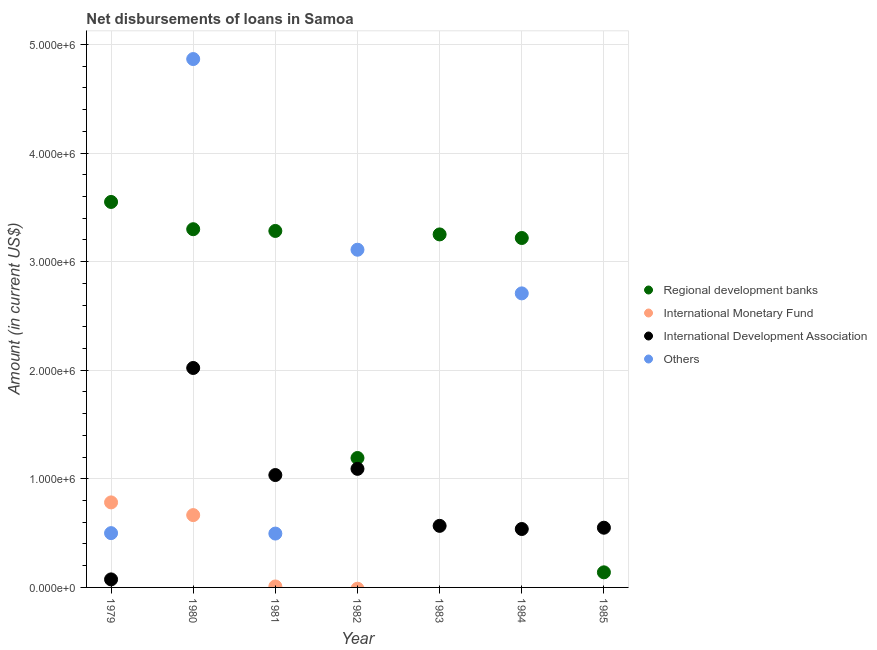How many different coloured dotlines are there?
Ensure brevity in your answer.  4. What is the amount of loan disimbursed by other organisations in 1980?
Make the answer very short. 4.87e+06. Across all years, what is the maximum amount of loan disimbursed by international development association?
Offer a terse response. 2.02e+06. Across all years, what is the minimum amount of loan disimbursed by international development association?
Offer a terse response. 7.40e+04. What is the total amount of loan disimbursed by international development association in the graph?
Offer a very short reply. 5.88e+06. What is the difference between the amount of loan disimbursed by regional development banks in 1979 and that in 1982?
Ensure brevity in your answer.  2.36e+06. What is the difference between the amount of loan disimbursed by international development association in 1979 and the amount of loan disimbursed by other organisations in 1984?
Offer a very short reply. -2.63e+06. What is the average amount of loan disimbursed by other organisations per year?
Your response must be concise. 1.67e+06. In the year 1979, what is the difference between the amount of loan disimbursed by regional development banks and amount of loan disimbursed by international monetary fund?
Your response must be concise. 2.77e+06. What is the ratio of the amount of loan disimbursed by international development association in 1981 to that in 1984?
Keep it short and to the point. 1.92. What is the difference between the highest and the second highest amount of loan disimbursed by international monetary fund?
Your response must be concise. 1.17e+05. What is the difference between the highest and the lowest amount of loan disimbursed by regional development banks?
Offer a very short reply. 3.41e+06. Is it the case that in every year, the sum of the amount of loan disimbursed by regional development banks and amount of loan disimbursed by international monetary fund is greater than the amount of loan disimbursed by international development association?
Your answer should be compact. No. Does the amount of loan disimbursed by regional development banks monotonically increase over the years?
Offer a terse response. No. Is the amount of loan disimbursed by other organisations strictly greater than the amount of loan disimbursed by international development association over the years?
Your answer should be very brief. No. How many dotlines are there?
Keep it short and to the point. 4. How many years are there in the graph?
Provide a succinct answer. 7. How many legend labels are there?
Your answer should be compact. 4. What is the title of the graph?
Keep it short and to the point. Net disbursements of loans in Samoa. Does "Revenue mobilization" appear as one of the legend labels in the graph?
Keep it short and to the point. No. What is the label or title of the X-axis?
Your response must be concise. Year. What is the label or title of the Y-axis?
Keep it short and to the point. Amount (in current US$). What is the Amount (in current US$) of Regional development banks in 1979?
Keep it short and to the point. 3.55e+06. What is the Amount (in current US$) in International Monetary Fund in 1979?
Offer a very short reply. 7.83e+05. What is the Amount (in current US$) in International Development Association in 1979?
Your answer should be very brief. 7.40e+04. What is the Amount (in current US$) in Regional development banks in 1980?
Provide a short and direct response. 3.30e+06. What is the Amount (in current US$) in International Monetary Fund in 1980?
Provide a short and direct response. 6.66e+05. What is the Amount (in current US$) of International Development Association in 1980?
Ensure brevity in your answer.  2.02e+06. What is the Amount (in current US$) in Others in 1980?
Offer a very short reply. 4.87e+06. What is the Amount (in current US$) of Regional development banks in 1981?
Make the answer very short. 3.28e+06. What is the Amount (in current US$) of International Monetary Fund in 1981?
Ensure brevity in your answer.  9000. What is the Amount (in current US$) of International Development Association in 1981?
Your response must be concise. 1.04e+06. What is the Amount (in current US$) of Others in 1981?
Provide a succinct answer. 4.96e+05. What is the Amount (in current US$) of Regional development banks in 1982?
Your answer should be very brief. 1.19e+06. What is the Amount (in current US$) of International Monetary Fund in 1982?
Offer a terse response. 0. What is the Amount (in current US$) in International Development Association in 1982?
Your answer should be compact. 1.09e+06. What is the Amount (in current US$) of Others in 1982?
Offer a very short reply. 3.11e+06. What is the Amount (in current US$) of Regional development banks in 1983?
Your answer should be very brief. 3.25e+06. What is the Amount (in current US$) in International Monetary Fund in 1983?
Keep it short and to the point. 0. What is the Amount (in current US$) in International Development Association in 1983?
Your answer should be compact. 5.67e+05. What is the Amount (in current US$) of Others in 1983?
Offer a terse response. 0. What is the Amount (in current US$) in Regional development banks in 1984?
Your answer should be compact. 3.22e+06. What is the Amount (in current US$) in International Development Association in 1984?
Your response must be concise. 5.38e+05. What is the Amount (in current US$) in Others in 1984?
Offer a very short reply. 2.71e+06. What is the Amount (in current US$) in Regional development banks in 1985?
Your answer should be very brief. 1.39e+05. What is the Amount (in current US$) of International Monetary Fund in 1985?
Keep it short and to the point. 0. Across all years, what is the maximum Amount (in current US$) in Regional development banks?
Ensure brevity in your answer.  3.55e+06. Across all years, what is the maximum Amount (in current US$) in International Monetary Fund?
Your answer should be very brief. 7.83e+05. Across all years, what is the maximum Amount (in current US$) of International Development Association?
Ensure brevity in your answer.  2.02e+06. Across all years, what is the maximum Amount (in current US$) in Others?
Provide a short and direct response. 4.87e+06. Across all years, what is the minimum Amount (in current US$) in Regional development banks?
Keep it short and to the point. 1.39e+05. Across all years, what is the minimum Amount (in current US$) in International Monetary Fund?
Provide a succinct answer. 0. Across all years, what is the minimum Amount (in current US$) of International Development Association?
Provide a short and direct response. 7.40e+04. What is the total Amount (in current US$) in Regional development banks in the graph?
Offer a very short reply. 1.79e+07. What is the total Amount (in current US$) of International Monetary Fund in the graph?
Your answer should be compact. 1.46e+06. What is the total Amount (in current US$) of International Development Association in the graph?
Provide a succinct answer. 5.88e+06. What is the total Amount (in current US$) in Others in the graph?
Your answer should be compact. 1.17e+07. What is the difference between the Amount (in current US$) in Regional development banks in 1979 and that in 1980?
Provide a succinct answer. 2.51e+05. What is the difference between the Amount (in current US$) in International Monetary Fund in 1979 and that in 1980?
Your answer should be very brief. 1.17e+05. What is the difference between the Amount (in current US$) in International Development Association in 1979 and that in 1980?
Offer a very short reply. -1.95e+06. What is the difference between the Amount (in current US$) in Others in 1979 and that in 1980?
Offer a very short reply. -4.37e+06. What is the difference between the Amount (in current US$) in Regional development banks in 1979 and that in 1981?
Give a very brief answer. 2.67e+05. What is the difference between the Amount (in current US$) of International Monetary Fund in 1979 and that in 1981?
Your answer should be very brief. 7.74e+05. What is the difference between the Amount (in current US$) in International Development Association in 1979 and that in 1981?
Your answer should be compact. -9.61e+05. What is the difference between the Amount (in current US$) of Others in 1979 and that in 1981?
Keep it short and to the point. 4000. What is the difference between the Amount (in current US$) of Regional development banks in 1979 and that in 1982?
Ensure brevity in your answer.  2.36e+06. What is the difference between the Amount (in current US$) in International Development Association in 1979 and that in 1982?
Provide a succinct answer. -1.02e+06. What is the difference between the Amount (in current US$) in Others in 1979 and that in 1982?
Offer a terse response. -2.61e+06. What is the difference between the Amount (in current US$) in Regional development banks in 1979 and that in 1983?
Ensure brevity in your answer.  2.99e+05. What is the difference between the Amount (in current US$) in International Development Association in 1979 and that in 1983?
Offer a terse response. -4.93e+05. What is the difference between the Amount (in current US$) of Regional development banks in 1979 and that in 1984?
Your answer should be very brief. 3.32e+05. What is the difference between the Amount (in current US$) of International Development Association in 1979 and that in 1984?
Provide a succinct answer. -4.64e+05. What is the difference between the Amount (in current US$) of Others in 1979 and that in 1984?
Ensure brevity in your answer.  -2.21e+06. What is the difference between the Amount (in current US$) in Regional development banks in 1979 and that in 1985?
Your response must be concise. 3.41e+06. What is the difference between the Amount (in current US$) of International Development Association in 1979 and that in 1985?
Provide a short and direct response. -4.76e+05. What is the difference between the Amount (in current US$) of Regional development banks in 1980 and that in 1981?
Offer a terse response. 1.60e+04. What is the difference between the Amount (in current US$) of International Monetary Fund in 1980 and that in 1981?
Your answer should be very brief. 6.57e+05. What is the difference between the Amount (in current US$) of International Development Association in 1980 and that in 1981?
Your response must be concise. 9.86e+05. What is the difference between the Amount (in current US$) in Others in 1980 and that in 1981?
Ensure brevity in your answer.  4.37e+06. What is the difference between the Amount (in current US$) of Regional development banks in 1980 and that in 1982?
Ensure brevity in your answer.  2.11e+06. What is the difference between the Amount (in current US$) of International Development Association in 1980 and that in 1982?
Your answer should be very brief. 9.29e+05. What is the difference between the Amount (in current US$) of Others in 1980 and that in 1982?
Provide a short and direct response. 1.76e+06. What is the difference between the Amount (in current US$) of Regional development banks in 1980 and that in 1983?
Offer a very short reply. 4.80e+04. What is the difference between the Amount (in current US$) of International Development Association in 1980 and that in 1983?
Your answer should be compact. 1.45e+06. What is the difference between the Amount (in current US$) in Regional development banks in 1980 and that in 1984?
Your answer should be very brief. 8.10e+04. What is the difference between the Amount (in current US$) of International Development Association in 1980 and that in 1984?
Provide a succinct answer. 1.48e+06. What is the difference between the Amount (in current US$) of Others in 1980 and that in 1984?
Give a very brief answer. 2.16e+06. What is the difference between the Amount (in current US$) of Regional development banks in 1980 and that in 1985?
Make the answer very short. 3.16e+06. What is the difference between the Amount (in current US$) of International Development Association in 1980 and that in 1985?
Give a very brief answer. 1.47e+06. What is the difference between the Amount (in current US$) in Regional development banks in 1981 and that in 1982?
Provide a succinct answer. 2.09e+06. What is the difference between the Amount (in current US$) in International Development Association in 1981 and that in 1982?
Ensure brevity in your answer.  -5.70e+04. What is the difference between the Amount (in current US$) of Others in 1981 and that in 1982?
Offer a very short reply. -2.61e+06. What is the difference between the Amount (in current US$) of Regional development banks in 1981 and that in 1983?
Your response must be concise. 3.20e+04. What is the difference between the Amount (in current US$) of International Development Association in 1981 and that in 1983?
Your answer should be compact. 4.68e+05. What is the difference between the Amount (in current US$) of Regional development banks in 1981 and that in 1984?
Your answer should be very brief. 6.50e+04. What is the difference between the Amount (in current US$) of International Development Association in 1981 and that in 1984?
Your answer should be compact. 4.97e+05. What is the difference between the Amount (in current US$) in Others in 1981 and that in 1984?
Your answer should be compact. -2.21e+06. What is the difference between the Amount (in current US$) in Regional development banks in 1981 and that in 1985?
Offer a terse response. 3.14e+06. What is the difference between the Amount (in current US$) in International Development Association in 1981 and that in 1985?
Give a very brief answer. 4.85e+05. What is the difference between the Amount (in current US$) of Regional development banks in 1982 and that in 1983?
Your answer should be very brief. -2.06e+06. What is the difference between the Amount (in current US$) of International Development Association in 1982 and that in 1983?
Ensure brevity in your answer.  5.25e+05. What is the difference between the Amount (in current US$) in Regional development banks in 1982 and that in 1984?
Offer a very short reply. -2.03e+06. What is the difference between the Amount (in current US$) of International Development Association in 1982 and that in 1984?
Your response must be concise. 5.54e+05. What is the difference between the Amount (in current US$) of Others in 1982 and that in 1984?
Provide a short and direct response. 4.02e+05. What is the difference between the Amount (in current US$) in Regional development banks in 1982 and that in 1985?
Your response must be concise. 1.05e+06. What is the difference between the Amount (in current US$) in International Development Association in 1982 and that in 1985?
Offer a terse response. 5.42e+05. What is the difference between the Amount (in current US$) in Regional development banks in 1983 and that in 1984?
Your response must be concise. 3.30e+04. What is the difference between the Amount (in current US$) in International Development Association in 1983 and that in 1984?
Your response must be concise. 2.90e+04. What is the difference between the Amount (in current US$) in Regional development banks in 1983 and that in 1985?
Give a very brief answer. 3.11e+06. What is the difference between the Amount (in current US$) in International Development Association in 1983 and that in 1985?
Offer a very short reply. 1.70e+04. What is the difference between the Amount (in current US$) of Regional development banks in 1984 and that in 1985?
Give a very brief answer. 3.08e+06. What is the difference between the Amount (in current US$) in International Development Association in 1984 and that in 1985?
Ensure brevity in your answer.  -1.20e+04. What is the difference between the Amount (in current US$) of Regional development banks in 1979 and the Amount (in current US$) of International Monetary Fund in 1980?
Provide a short and direct response. 2.88e+06. What is the difference between the Amount (in current US$) in Regional development banks in 1979 and the Amount (in current US$) in International Development Association in 1980?
Provide a succinct answer. 1.53e+06. What is the difference between the Amount (in current US$) of Regional development banks in 1979 and the Amount (in current US$) of Others in 1980?
Provide a succinct answer. -1.32e+06. What is the difference between the Amount (in current US$) of International Monetary Fund in 1979 and the Amount (in current US$) of International Development Association in 1980?
Provide a short and direct response. -1.24e+06. What is the difference between the Amount (in current US$) of International Monetary Fund in 1979 and the Amount (in current US$) of Others in 1980?
Ensure brevity in your answer.  -4.08e+06. What is the difference between the Amount (in current US$) in International Development Association in 1979 and the Amount (in current US$) in Others in 1980?
Keep it short and to the point. -4.79e+06. What is the difference between the Amount (in current US$) in Regional development banks in 1979 and the Amount (in current US$) in International Monetary Fund in 1981?
Your answer should be compact. 3.54e+06. What is the difference between the Amount (in current US$) in Regional development banks in 1979 and the Amount (in current US$) in International Development Association in 1981?
Keep it short and to the point. 2.52e+06. What is the difference between the Amount (in current US$) of Regional development banks in 1979 and the Amount (in current US$) of Others in 1981?
Offer a terse response. 3.05e+06. What is the difference between the Amount (in current US$) of International Monetary Fund in 1979 and the Amount (in current US$) of International Development Association in 1981?
Give a very brief answer. -2.52e+05. What is the difference between the Amount (in current US$) of International Monetary Fund in 1979 and the Amount (in current US$) of Others in 1981?
Keep it short and to the point. 2.87e+05. What is the difference between the Amount (in current US$) of International Development Association in 1979 and the Amount (in current US$) of Others in 1981?
Keep it short and to the point. -4.22e+05. What is the difference between the Amount (in current US$) of Regional development banks in 1979 and the Amount (in current US$) of International Development Association in 1982?
Provide a succinct answer. 2.46e+06. What is the difference between the Amount (in current US$) in International Monetary Fund in 1979 and the Amount (in current US$) in International Development Association in 1982?
Provide a succinct answer. -3.09e+05. What is the difference between the Amount (in current US$) of International Monetary Fund in 1979 and the Amount (in current US$) of Others in 1982?
Offer a terse response. -2.33e+06. What is the difference between the Amount (in current US$) of International Development Association in 1979 and the Amount (in current US$) of Others in 1982?
Keep it short and to the point. -3.04e+06. What is the difference between the Amount (in current US$) of Regional development banks in 1979 and the Amount (in current US$) of International Development Association in 1983?
Keep it short and to the point. 2.98e+06. What is the difference between the Amount (in current US$) of International Monetary Fund in 1979 and the Amount (in current US$) of International Development Association in 1983?
Give a very brief answer. 2.16e+05. What is the difference between the Amount (in current US$) of Regional development banks in 1979 and the Amount (in current US$) of International Development Association in 1984?
Your answer should be very brief. 3.01e+06. What is the difference between the Amount (in current US$) of Regional development banks in 1979 and the Amount (in current US$) of Others in 1984?
Keep it short and to the point. 8.42e+05. What is the difference between the Amount (in current US$) in International Monetary Fund in 1979 and the Amount (in current US$) in International Development Association in 1984?
Provide a short and direct response. 2.45e+05. What is the difference between the Amount (in current US$) of International Monetary Fund in 1979 and the Amount (in current US$) of Others in 1984?
Offer a terse response. -1.92e+06. What is the difference between the Amount (in current US$) in International Development Association in 1979 and the Amount (in current US$) in Others in 1984?
Make the answer very short. -2.63e+06. What is the difference between the Amount (in current US$) of Regional development banks in 1979 and the Amount (in current US$) of International Development Association in 1985?
Offer a terse response. 3.00e+06. What is the difference between the Amount (in current US$) of International Monetary Fund in 1979 and the Amount (in current US$) of International Development Association in 1985?
Make the answer very short. 2.33e+05. What is the difference between the Amount (in current US$) of Regional development banks in 1980 and the Amount (in current US$) of International Monetary Fund in 1981?
Give a very brief answer. 3.29e+06. What is the difference between the Amount (in current US$) in Regional development banks in 1980 and the Amount (in current US$) in International Development Association in 1981?
Your response must be concise. 2.26e+06. What is the difference between the Amount (in current US$) of Regional development banks in 1980 and the Amount (in current US$) of Others in 1981?
Your answer should be compact. 2.80e+06. What is the difference between the Amount (in current US$) of International Monetary Fund in 1980 and the Amount (in current US$) of International Development Association in 1981?
Ensure brevity in your answer.  -3.69e+05. What is the difference between the Amount (in current US$) in International Development Association in 1980 and the Amount (in current US$) in Others in 1981?
Offer a terse response. 1.52e+06. What is the difference between the Amount (in current US$) of Regional development banks in 1980 and the Amount (in current US$) of International Development Association in 1982?
Ensure brevity in your answer.  2.21e+06. What is the difference between the Amount (in current US$) of Regional development banks in 1980 and the Amount (in current US$) of Others in 1982?
Offer a terse response. 1.89e+05. What is the difference between the Amount (in current US$) of International Monetary Fund in 1980 and the Amount (in current US$) of International Development Association in 1982?
Offer a very short reply. -4.26e+05. What is the difference between the Amount (in current US$) of International Monetary Fund in 1980 and the Amount (in current US$) of Others in 1982?
Keep it short and to the point. -2.44e+06. What is the difference between the Amount (in current US$) in International Development Association in 1980 and the Amount (in current US$) in Others in 1982?
Provide a short and direct response. -1.09e+06. What is the difference between the Amount (in current US$) of Regional development banks in 1980 and the Amount (in current US$) of International Development Association in 1983?
Your answer should be compact. 2.73e+06. What is the difference between the Amount (in current US$) in International Monetary Fund in 1980 and the Amount (in current US$) in International Development Association in 1983?
Keep it short and to the point. 9.90e+04. What is the difference between the Amount (in current US$) of Regional development banks in 1980 and the Amount (in current US$) of International Development Association in 1984?
Give a very brief answer. 2.76e+06. What is the difference between the Amount (in current US$) of Regional development banks in 1980 and the Amount (in current US$) of Others in 1984?
Provide a short and direct response. 5.91e+05. What is the difference between the Amount (in current US$) in International Monetary Fund in 1980 and the Amount (in current US$) in International Development Association in 1984?
Offer a very short reply. 1.28e+05. What is the difference between the Amount (in current US$) of International Monetary Fund in 1980 and the Amount (in current US$) of Others in 1984?
Provide a short and direct response. -2.04e+06. What is the difference between the Amount (in current US$) in International Development Association in 1980 and the Amount (in current US$) in Others in 1984?
Your answer should be very brief. -6.87e+05. What is the difference between the Amount (in current US$) of Regional development banks in 1980 and the Amount (in current US$) of International Development Association in 1985?
Offer a very short reply. 2.75e+06. What is the difference between the Amount (in current US$) in International Monetary Fund in 1980 and the Amount (in current US$) in International Development Association in 1985?
Your response must be concise. 1.16e+05. What is the difference between the Amount (in current US$) in Regional development banks in 1981 and the Amount (in current US$) in International Development Association in 1982?
Your response must be concise. 2.19e+06. What is the difference between the Amount (in current US$) in Regional development banks in 1981 and the Amount (in current US$) in Others in 1982?
Ensure brevity in your answer.  1.73e+05. What is the difference between the Amount (in current US$) in International Monetary Fund in 1981 and the Amount (in current US$) in International Development Association in 1982?
Keep it short and to the point. -1.08e+06. What is the difference between the Amount (in current US$) in International Monetary Fund in 1981 and the Amount (in current US$) in Others in 1982?
Ensure brevity in your answer.  -3.10e+06. What is the difference between the Amount (in current US$) in International Development Association in 1981 and the Amount (in current US$) in Others in 1982?
Your response must be concise. -2.08e+06. What is the difference between the Amount (in current US$) of Regional development banks in 1981 and the Amount (in current US$) of International Development Association in 1983?
Offer a terse response. 2.72e+06. What is the difference between the Amount (in current US$) in International Monetary Fund in 1981 and the Amount (in current US$) in International Development Association in 1983?
Give a very brief answer. -5.58e+05. What is the difference between the Amount (in current US$) of Regional development banks in 1981 and the Amount (in current US$) of International Development Association in 1984?
Ensure brevity in your answer.  2.74e+06. What is the difference between the Amount (in current US$) in Regional development banks in 1981 and the Amount (in current US$) in Others in 1984?
Your answer should be compact. 5.75e+05. What is the difference between the Amount (in current US$) of International Monetary Fund in 1981 and the Amount (in current US$) of International Development Association in 1984?
Make the answer very short. -5.29e+05. What is the difference between the Amount (in current US$) of International Monetary Fund in 1981 and the Amount (in current US$) of Others in 1984?
Offer a very short reply. -2.70e+06. What is the difference between the Amount (in current US$) of International Development Association in 1981 and the Amount (in current US$) of Others in 1984?
Offer a terse response. -1.67e+06. What is the difference between the Amount (in current US$) in Regional development banks in 1981 and the Amount (in current US$) in International Development Association in 1985?
Give a very brief answer. 2.73e+06. What is the difference between the Amount (in current US$) of International Monetary Fund in 1981 and the Amount (in current US$) of International Development Association in 1985?
Offer a very short reply. -5.41e+05. What is the difference between the Amount (in current US$) of Regional development banks in 1982 and the Amount (in current US$) of International Development Association in 1983?
Offer a very short reply. 6.25e+05. What is the difference between the Amount (in current US$) of Regional development banks in 1982 and the Amount (in current US$) of International Development Association in 1984?
Your answer should be very brief. 6.54e+05. What is the difference between the Amount (in current US$) of Regional development banks in 1982 and the Amount (in current US$) of Others in 1984?
Your answer should be compact. -1.52e+06. What is the difference between the Amount (in current US$) in International Development Association in 1982 and the Amount (in current US$) in Others in 1984?
Keep it short and to the point. -1.62e+06. What is the difference between the Amount (in current US$) in Regional development banks in 1982 and the Amount (in current US$) in International Development Association in 1985?
Provide a succinct answer. 6.42e+05. What is the difference between the Amount (in current US$) of Regional development banks in 1983 and the Amount (in current US$) of International Development Association in 1984?
Provide a succinct answer. 2.71e+06. What is the difference between the Amount (in current US$) of Regional development banks in 1983 and the Amount (in current US$) of Others in 1984?
Provide a short and direct response. 5.43e+05. What is the difference between the Amount (in current US$) of International Development Association in 1983 and the Amount (in current US$) of Others in 1984?
Offer a terse response. -2.14e+06. What is the difference between the Amount (in current US$) of Regional development banks in 1983 and the Amount (in current US$) of International Development Association in 1985?
Keep it short and to the point. 2.70e+06. What is the difference between the Amount (in current US$) of Regional development banks in 1984 and the Amount (in current US$) of International Development Association in 1985?
Provide a succinct answer. 2.67e+06. What is the average Amount (in current US$) of Regional development banks per year?
Offer a terse response. 2.56e+06. What is the average Amount (in current US$) in International Monetary Fund per year?
Offer a terse response. 2.08e+05. What is the average Amount (in current US$) of International Development Association per year?
Your answer should be very brief. 8.40e+05. What is the average Amount (in current US$) of Others per year?
Make the answer very short. 1.67e+06. In the year 1979, what is the difference between the Amount (in current US$) of Regional development banks and Amount (in current US$) of International Monetary Fund?
Provide a succinct answer. 2.77e+06. In the year 1979, what is the difference between the Amount (in current US$) in Regional development banks and Amount (in current US$) in International Development Association?
Your response must be concise. 3.48e+06. In the year 1979, what is the difference between the Amount (in current US$) in Regional development banks and Amount (in current US$) in Others?
Keep it short and to the point. 3.05e+06. In the year 1979, what is the difference between the Amount (in current US$) of International Monetary Fund and Amount (in current US$) of International Development Association?
Provide a short and direct response. 7.09e+05. In the year 1979, what is the difference between the Amount (in current US$) in International Monetary Fund and Amount (in current US$) in Others?
Give a very brief answer. 2.83e+05. In the year 1979, what is the difference between the Amount (in current US$) in International Development Association and Amount (in current US$) in Others?
Make the answer very short. -4.26e+05. In the year 1980, what is the difference between the Amount (in current US$) of Regional development banks and Amount (in current US$) of International Monetary Fund?
Offer a terse response. 2.63e+06. In the year 1980, what is the difference between the Amount (in current US$) of Regional development banks and Amount (in current US$) of International Development Association?
Offer a terse response. 1.28e+06. In the year 1980, what is the difference between the Amount (in current US$) in Regional development banks and Amount (in current US$) in Others?
Provide a succinct answer. -1.57e+06. In the year 1980, what is the difference between the Amount (in current US$) in International Monetary Fund and Amount (in current US$) in International Development Association?
Offer a very short reply. -1.36e+06. In the year 1980, what is the difference between the Amount (in current US$) in International Monetary Fund and Amount (in current US$) in Others?
Offer a terse response. -4.20e+06. In the year 1980, what is the difference between the Amount (in current US$) of International Development Association and Amount (in current US$) of Others?
Your answer should be compact. -2.84e+06. In the year 1981, what is the difference between the Amount (in current US$) of Regional development banks and Amount (in current US$) of International Monetary Fund?
Your answer should be very brief. 3.27e+06. In the year 1981, what is the difference between the Amount (in current US$) of Regional development banks and Amount (in current US$) of International Development Association?
Provide a succinct answer. 2.25e+06. In the year 1981, what is the difference between the Amount (in current US$) of Regional development banks and Amount (in current US$) of Others?
Give a very brief answer. 2.79e+06. In the year 1981, what is the difference between the Amount (in current US$) in International Monetary Fund and Amount (in current US$) in International Development Association?
Keep it short and to the point. -1.03e+06. In the year 1981, what is the difference between the Amount (in current US$) of International Monetary Fund and Amount (in current US$) of Others?
Give a very brief answer. -4.87e+05. In the year 1981, what is the difference between the Amount (in current US$) in International Development Association and Amount (in current US$) in Others?
Give a very brief answer. 5.39e+05. In the year 1982, what is the difference between the Amount (in current US$) of Regional development banks and Amount (in current US$) of International Development Association?
Your answer should be very brief. 1.00e+05. In the year 1982, what is the difference between the Amount (in current US$) of Regional development banks and Amount (in current US$) of Others?
Offer a very short reply. -1.92e+06. In the year 1982, what is the difference between the Amount (in current US$) in International Development Association and Amount (in current US$) in Others?
Provide a succinct answer. -2.02e+06. In the year 1983, what is the difference between the Amount (in current US$) in Regional development banks and Amount (in current US$) in International Development Association?
Make the answer very short. 2.68e+06. In the year 1984, what is the difference between the Amount (in current US$) of Regional development banks and Amount (in current US$) of International Development Association?
Your answer should be compact. 2.68e+06. In the year 1984, what is the difference between the Amount (in current US$) in Regional development banks and Amount (in current US$) in Others?
Provide a succinct answer. 5.10e+05. In the year 1984, what is the difference between the Amount (in current US$) of International Development Association and Amount (in current US$) of Others?
Provide a succinct answer. -2.17e+06. In the year 1985, what is the difference between the Amount (in current US$) of Regional development banks and Amount (in current US$) of International Development Association?
Your response must be concise. -4.11e+05. What is the ratio of the Amount (in current US$) in Regional development banks in 1979 to that in 1980?
Give a very brief answer. 1.08. What is the ratio of the Amount (in current US$) of International Monetary Fund in 1979 to that in 1980?
Offer a terse response. 1.18. What is the ratio of the Amount (in current US$) in International Development Association in 1979 to that in 1980?
Your answer should be very brief. 0.04. What is the ratio of the Amount (in current US$) in Others in 1979 to that in 1980?
Keep it short and to the point. 0.1. What is the ratio of the Amount (in current US$) in Regional development banks in 1979 to that in 1981?
Ensure brevity in your answer.  1.08. What is the ratio of the Amount (in current US$) of International Development Association in 1979 to that in 1981?
Your answer should be compact. 0.07. What is the ratio of the Amount (in current US$) of Others in 1979 to that in 1981?
Offer a terse response. 1.01. What is the ratio of the Amount (in current US$) of Regional development banks in 1979 to that in 1982?
Provide a succinct answer. 2.98. What is the ratio of the Amount (in current US$) in International Development Association in 1979 to that in 1982?
Give a very brief answer. 0.07. What is the ratio of the Amount (in current US$) in Others in 1979 to that in 1982?
Make the answer very short. 0.16. What is the ratio of the Amount (in current US$) in Regional development banks in 1979 to that in 1983?
Give a very brief answer. 1.09. What is the ratio of the Amount (in current US$) of International Development Association in 1979 to that in 1983?
Make the answer very short. 0.13. What is the ratio of the Amount (in current US$) of Regional development banks in 1979 to that in 1984?
Keep it short and to the point. 1.1. What is the ratio of the Amount (in current US$) in International Development Association in 1979 to that in 1984?
Offer a very short reply. 0.14. What is the ratio of the Amount (in current US$) of Others in 1979 to that in 1984?
Offer a very short reply. 0.18. What is the ratio of the Amount (in current US$) of Regional development banks in 1979 to that in 1985?
Offer a terse response. 25.54. What is the ratio of the Amount (in current US$) of International Development Association in 1979 to that in 1985?
Provide a short and direct response. 0.13. What is the ratio of the Amount (in current US$) of Regional development banks in 1980 to that in 1981?
Offer a terse response. 1. What is the ratio of the Amount (in current US$) of International Development Association in 1980 to that in 1981?
Give a very brief answer. 1.95. What is the ratio of the Amount (in current US$) in Others in 1980 to that in 1981?
Offer a very short reply. 9.81. What is the ratio of the Amount (in current US$) of Regional development banks in 1980 to that in 1982?
Your response must be concise. 2.77. What is the ratio of the Amount (in current US$) of International Development Association in 1980 to that in 1982?
Provide a succinct answer. 1.85. What is the ratio of the Amount (in current US$) in Others in 1980 to that in 1982?
Your response must be concise. 1.56. What is the ratio of the Amount (in current US$) of Regional development banks in 1980 to that in 1983?
Keep it short and to the point. 1.01. What is the ratio of the Amount (in current US$) of International Development Association in 1980 to that in 1983?
Make the answer very short. 3.56. What is the ratio of the Amount (in current US$) of Regional development banks in 1980 to that in 1984?
Offer a very short reply. 1.03. What is the ratio of the Amount (in current US$) of International Development Association in 1980 to that in 1984?
Your answer should be very brief. 3.76. What is the ratio of the Amount (in current US$) in Others in 1980 to that in 1984?
Your response must be concise. 1.8. What is the ratio of the Amount (in current US$) of Regional development banks in 1980 to that in 1985?
Offer a terse response. 23.73. What is the ratio of the Amount (in current US$) in International Development Association in 1980 to that in 1985?
Keep it short and to the point. 3.67. What is the ratio of the Amount (in current US$) in Regional development banks in 1981 to that in 1982?
Your response must be concise. 2.75. What is the ratio of the Amount (in current US$) in International Development Association in 1981 to that in 1982?
Offer a terse response. 0.95. What is the ratio of the Amount (in current US$) of Others in 1981 to that in 1982?
Provide a succinct answer. 0.16. What is the ratio of the Amount (in current US$) of Regional development banks in 1981 to that in 1983?
Your answer should be compact. 1.01. What is the ratio of the Amount (in current US$) of International Development Association in 1981 to that in 1983?
Provide a succinct answer. 1.83. What is the ratio of the Amount (in current US$) in Regional development banks in 1981 to that in 1984?
Keep it short and to the point. 1.02. What is the ratio of the Amount (in current US$) in International Development Association in 1981 to that in 1984?
Keep it short and to the point. 1.92. What is the ratio of the Amount (in current US$) of Others in 1981 to that in 1984?
Provide a short and direct response. 0.18. What is the ratio of the Amount (in current US$) of Regional development banks in 1981 to that in 1985?
Ensure brevity in your answer.  23.62. What is the ratio of the Amount (in current US$) of International Development Association in 1981 to that in 1985?
Your response must be concise. 1.88. What is the ratio of the Amount (in current US$) of Regional development banks in 1982 to that in 1983?
Keep it short and to the point. 0.37. What is the ratio of the Amount (in current US$) in International Development Association in 1982 to that in 1983?
Make the answer very short. 1.93. What is the ratio of the Amount (in current US$) in Regional development banks in 1982 to that in 1984?
Your response must be concise. 0.37. What is the ratio of the Amount (in current US$) of International Development Association in 1982 to that in 1984?
Provide a short and direct response. 2.03. What is the ratio of the Amount (in current US$) of Others in 1982 to that in 1984?
Your answer should be very brief. 1.15. What is the ratio of the Amount (in current US$) of Regional development banks in 1982 to that in 1985?
Your answer should be compact. 8.58. What is the ratio of the Amount (in current US$) of International Development Association in 1982 to that in 1985?
Make the answer very short. 1.99. What is the ratio of the Amount (in current US$) of Regional development banks in 1983 to that in 1984?
Your response must be concise. 1.01. What is the ratio of the Amount (in current US$) of International Development Association in 1983 to that in 1984?
Your response must be concise. 1.05. What is the ratio of the Amount (in current US$) in Regional development banks in 1983 to that in 1985?
Offer a terse response. 23.39. What is the ratio of the Amount (in current US$) of International Development Association in 1983 to that in 1985?
Your answer should be very brief. 1.03. What is the ratio of the Amount (in current US$) of Regional development banks in 1984 to that in 1985?
Ensure brevity in your answer.  23.15. What is the ratio of the Amount (in current US$) of International Development Association in 1984 to that in 1985?
Your answer should be very brief. 0.98. What is the difference between the highest and the second highest Amount (in current US$) of Regional development banks?
Your answer should be very brief. 2.51e+05. What is the difference between the highest and the second highest Amount (in current US$) in International Monetary Fund?
Offer a terse response. 1.17e+05. What is the difference between the highest and the second highest Amount (in current US$) of International Development Association?
Your response must be concise. 9.29e+05. What is the difference between the highest and the second highest Amount (in current US$) in Others?
Provide a succinct answer. 1.76e+06. What is the difference between the highest and the lowest Amount (in current US$) in Regional development banks?
Ensure brevity in your answer.  3.41e+06. What is the difference between the highest and the lowest Amount (in current US$) of International Monetary Fund?
Ensure brevity in your answer.  7.83e+05. What is the difference between the highest and the lowest Amount (in current US$) of International Development Association?
Your response must be concise. 1.95e+06. What is the difference between the highest and the lowest Amount (in current US$) in Others?
Your response must be concise. 4.87e+06. 